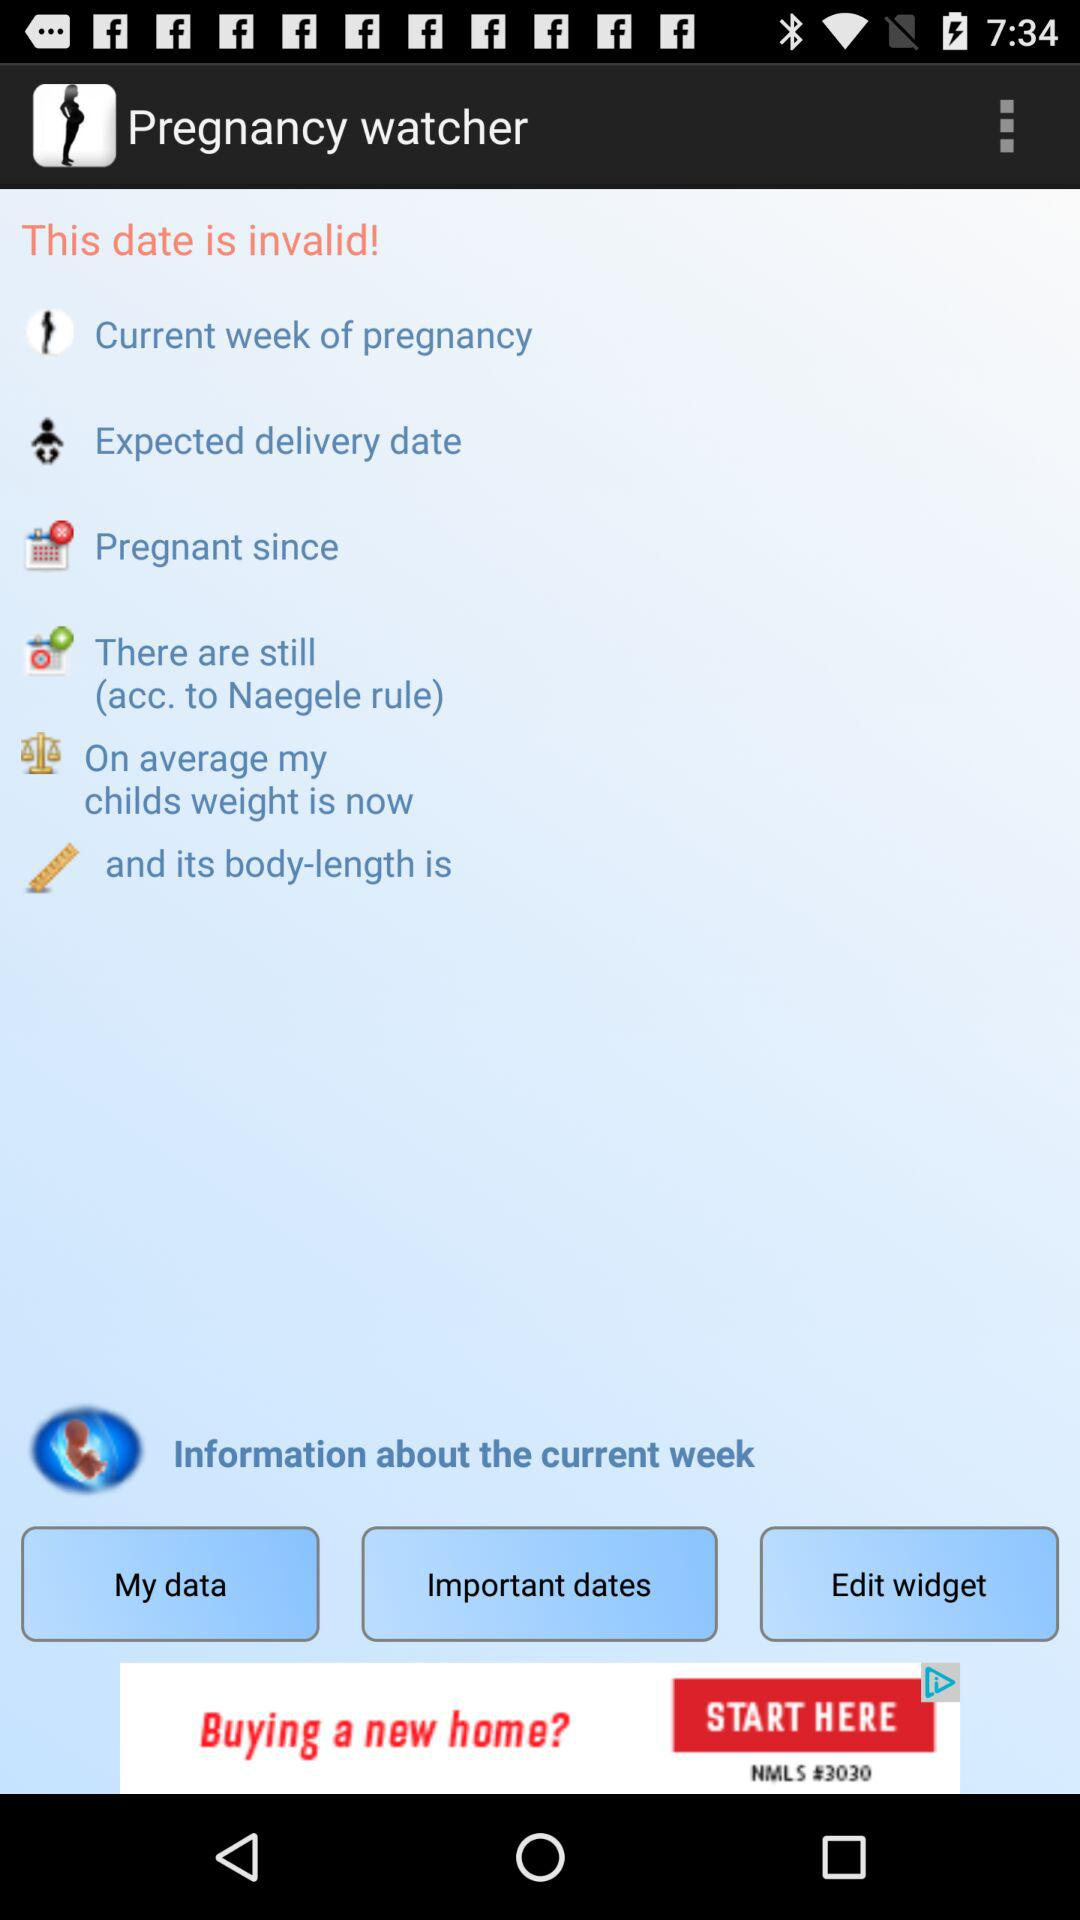What is the application name? The application name is "Pregnancy watcher". 